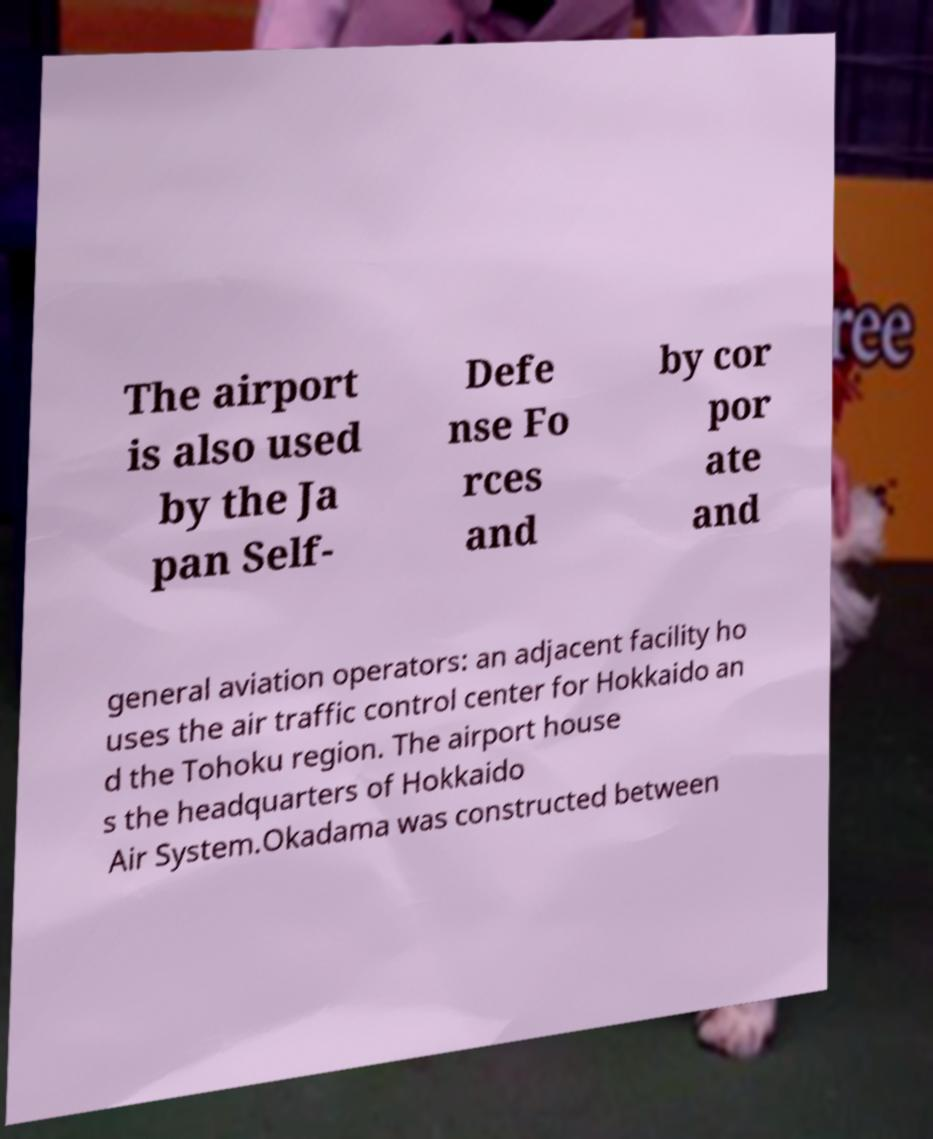Please read and relay the text visible in this image. What does it say? The airport is also used by the Ja pan Self- Defe nse Fo rces and by cor por ate and general aviation operators: an adjacent facility ho uses the air traffic control center for Hokkaido an d the Tohoku region. The airport house s the headquarters of Hokkaido Air System.Okadama was constructed between 